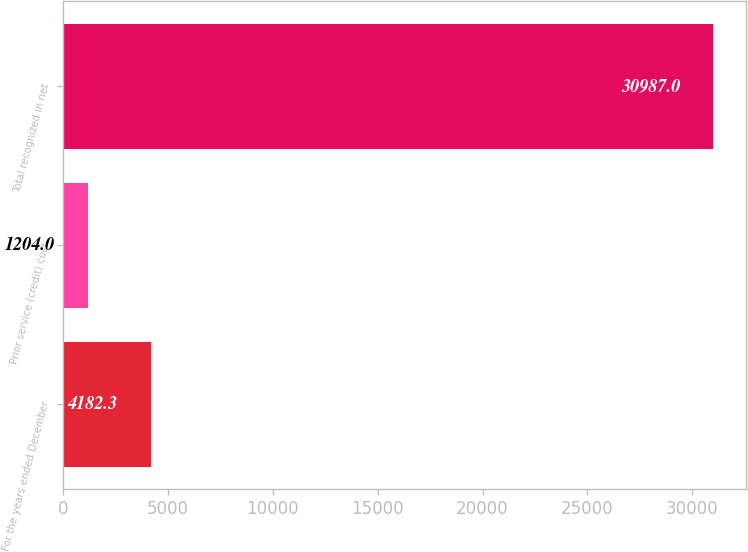Convert chart. <chart><loc_0><loc_0><loc_500><loc_500><bar_chart><fcel>For the years ended December<fcel>Prior service (credit) cost<fcel>Total recognized in net<nl><fcel>4182.3<fcel>1204<fcel>30987<nl></chart> 